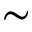Convert formula to latex. <formula><loc_0><loc_0><loc_500><loc_500>\sim</formula> 